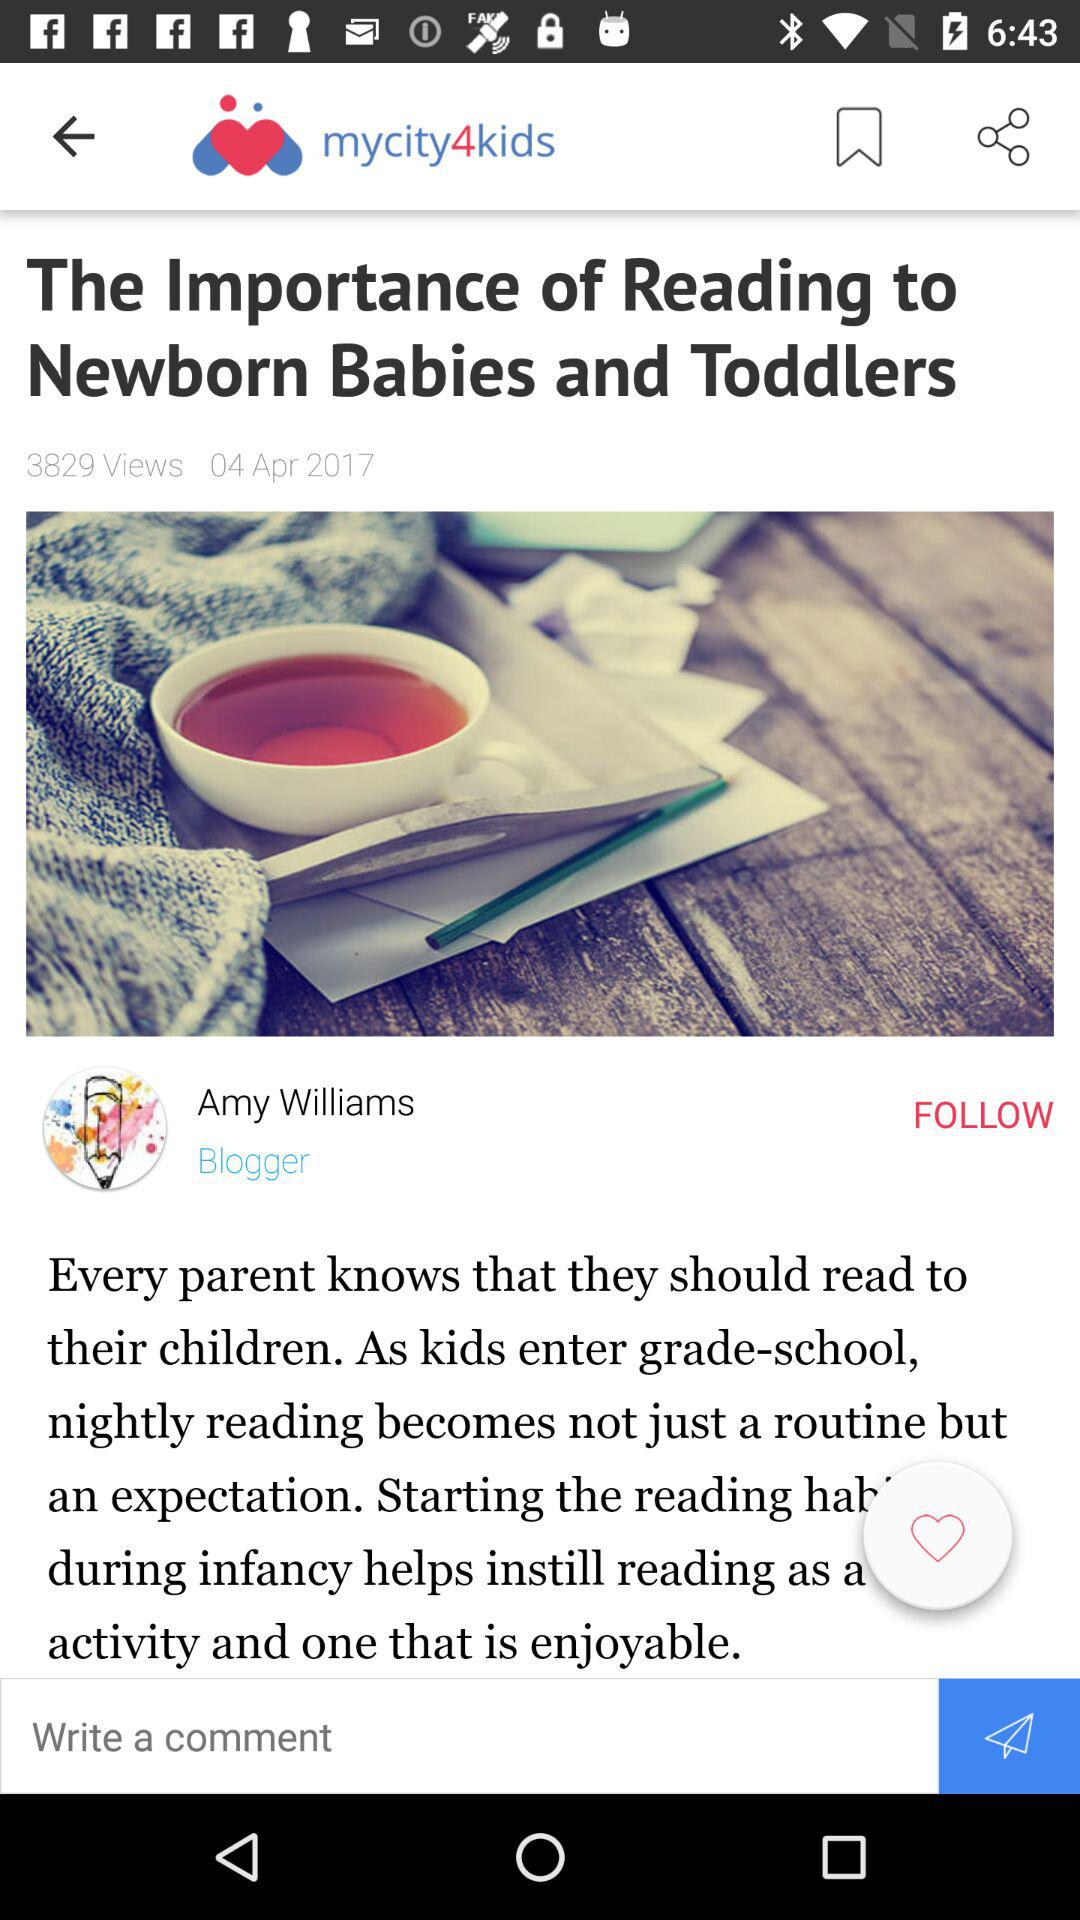Who is the blogger? The blogger is Amy Williams. 